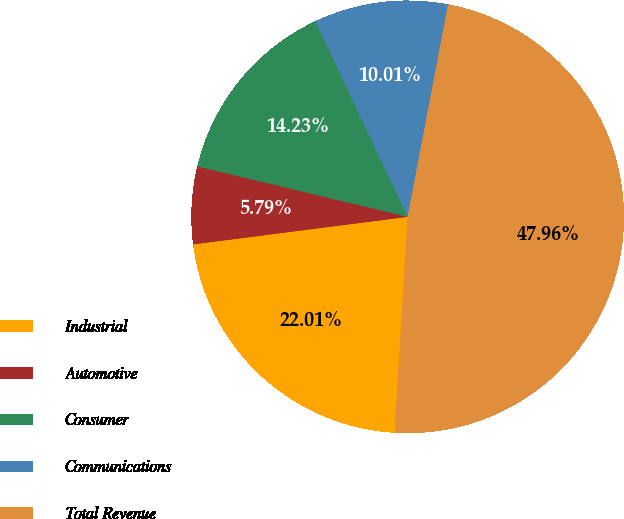Convert chart to OTSL. <chart><loc_0><loc_0><loc_500><loc_500><pie_chart><fcel>Industrial<fcel>Automotive<fcel>Consumer<fcel>Communications<fcel>Total Revenue<nl><fcel>22.01%<fcel>5.79%<fcel>14.23%<fcel>10.01%<fcel>47.96%<nl></chart> 